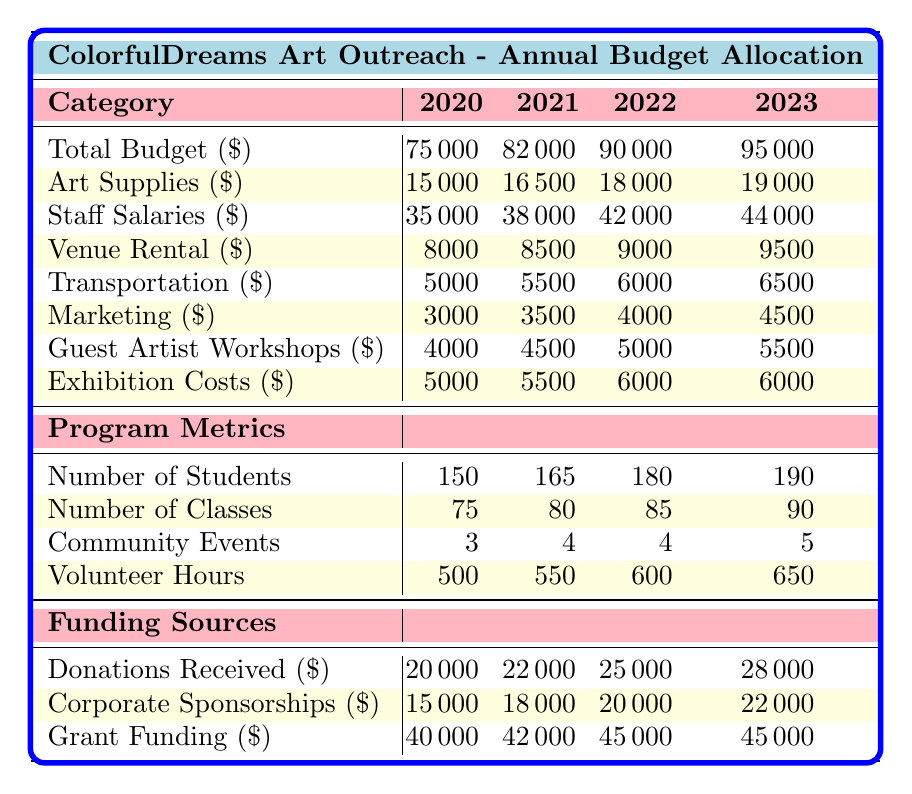What was the total budget in 2021? The table shows the total budget for each year. For 2021, the value is explicitly listed as 82,000.
Answer: 82,000 How much was allocated for Art Supplies in 2022? Looking at the row for Art Supplies, the budget for 2022 is 18,000.
Answer: 18,000 What is the percentage increase in Staff Salaries from 2020 to 2023? The Staff Salaries in 2020 were 35,000 and in 2023 they are 44,000. The increase is 44,000 - 35,000 = 9,000. To find the percentage increase: (9,000 / 35,000) × 100 = 25.71%.
Answer: 25.71% Did the number of students increase every year? The number of students was 150 in 2020 and increased to 190 in 2023. Checking each year: 150 to 165 (increase), 165 to 180 (increase), 180 to 190 (increase). Therefore, yes, there was an increase every year.
Answer: Yes What is the average budget allocated for marketing across the years? The marketing budgets are 3,000, 3,500, 4,000, and 4,500 for 2020 to 2023. Sum these values: 3,000 + 3,500 + 4,000 + 4,500 = 15,000. Divide by 4 (the number of years): 15,000 / 4 = 3,750.
Answer: 3,750 How much did Corporate Sponsorships increase from 2020 to 2022? The Corporate Sponsorships for 2020 was 15,000 and for 2022 it was 20,000. The increase is calculated as: 20,000 - 15,000 = 5,000.
Answer: 5,000 Was the total budget for 2023 higher than the sum of Art Supplies and Venue Rental in that year? In 2023, the total budget is 95,000. Adding the Art Supplies (19,000) and Venue Rental (9,500) for that year results in 19,000 + 9,500 = 28,500. Comparing, 95,000 is significantly higher than 28,500.
Answer: Yes What was the total Volunteer Hours for the years 2020 and 2021 combined? The total Volunteer Hours are 500 for 2020 and 550 for 2021. Adding these together yields 500 + 550 = 1,050.
Answer: 1,050 In which year did the program conduct the most Community Events? The table shows 3, 4, 4, and 5 Community Events from 2020 to 2023. The highest number is 5, which occurred in 2023.
Answer: 2023 What is the total amount received from Donations over the four years? The Donations Received are 20,000, 22,000, 25,000, and 28,000. Summing these amounts gives: 20,000 + 22,000 + 25,000 + 28,000 = 95,000.
Answer: 95,000 What is the trend in the number of classes over these years? The number of classes increased from 75 in 2020 to 90 in 2023. The values are 75, 80, 85, and 90, indicating an increase each year.
Answer: Increasing 